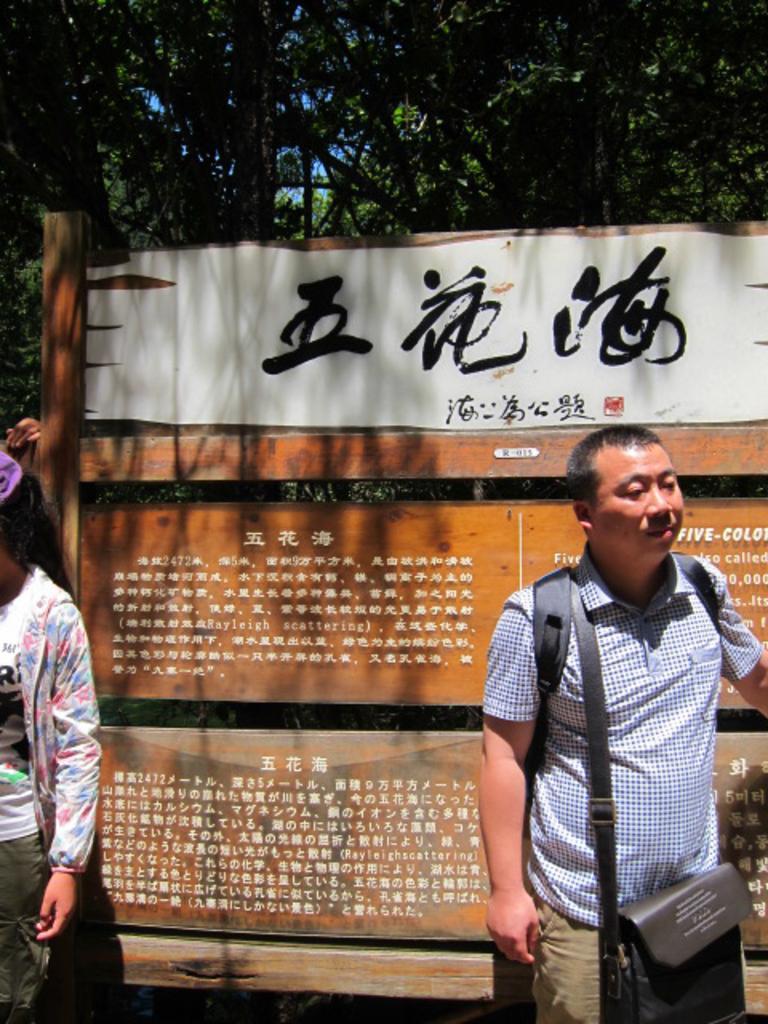Please provide a concise description of this image. In this image there are two people standing on the road behind them there is a hoarding and trees. 